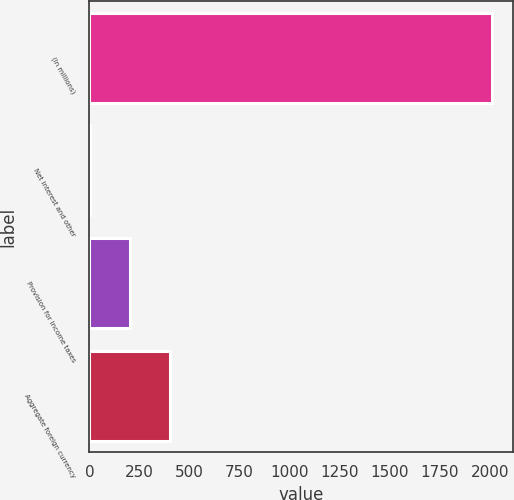<chart> <loc_0><loc_0><loc_500><loc_500><bar_chart><fcel>(In millions)<fcel>Net interest and other<fcel>Provision for income taxes<fcel>Aggregate foreign currency<nl><fcel>2012<fcel>2<fcel>203<fcel>404<nl></chart> 